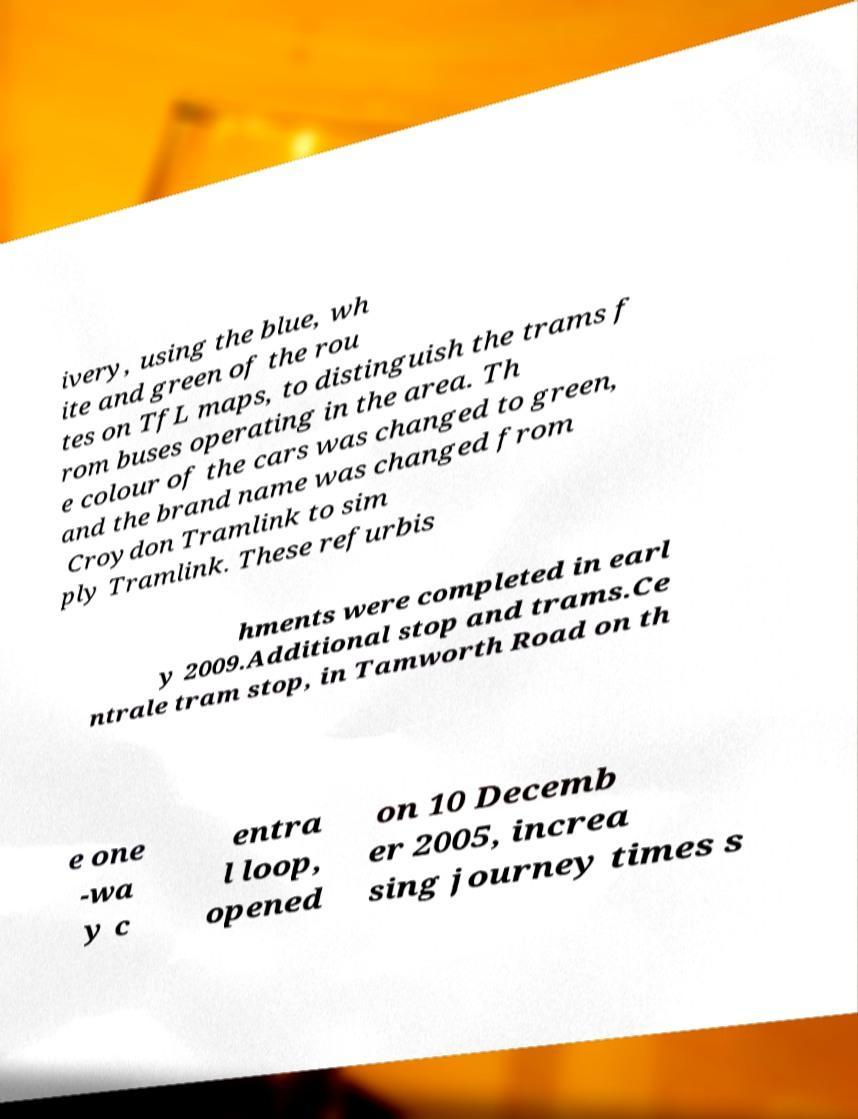I need the written content from this picture converted into text. Can you do that? ivery, using the blue, wh ite and green of the rou tes on TfL maps, to distinguish the trams f rom buses operating in the area. Th e colour of the cars was changed to green, and the brand name was changed from Croydon Tramlink to sim ply Tramlink. These refurbis hments were completed in earl y 2009.Additional stop and trams.Ce ntrale tram stop, in Tamworth Road on th e one -wa y c entra l loop, opened on 10 Decemb er 2005, increa sing journey times s 